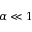<formula> <loc_0><loc_0><loc_500><loc_500>\alpha \ll 1</formula> 